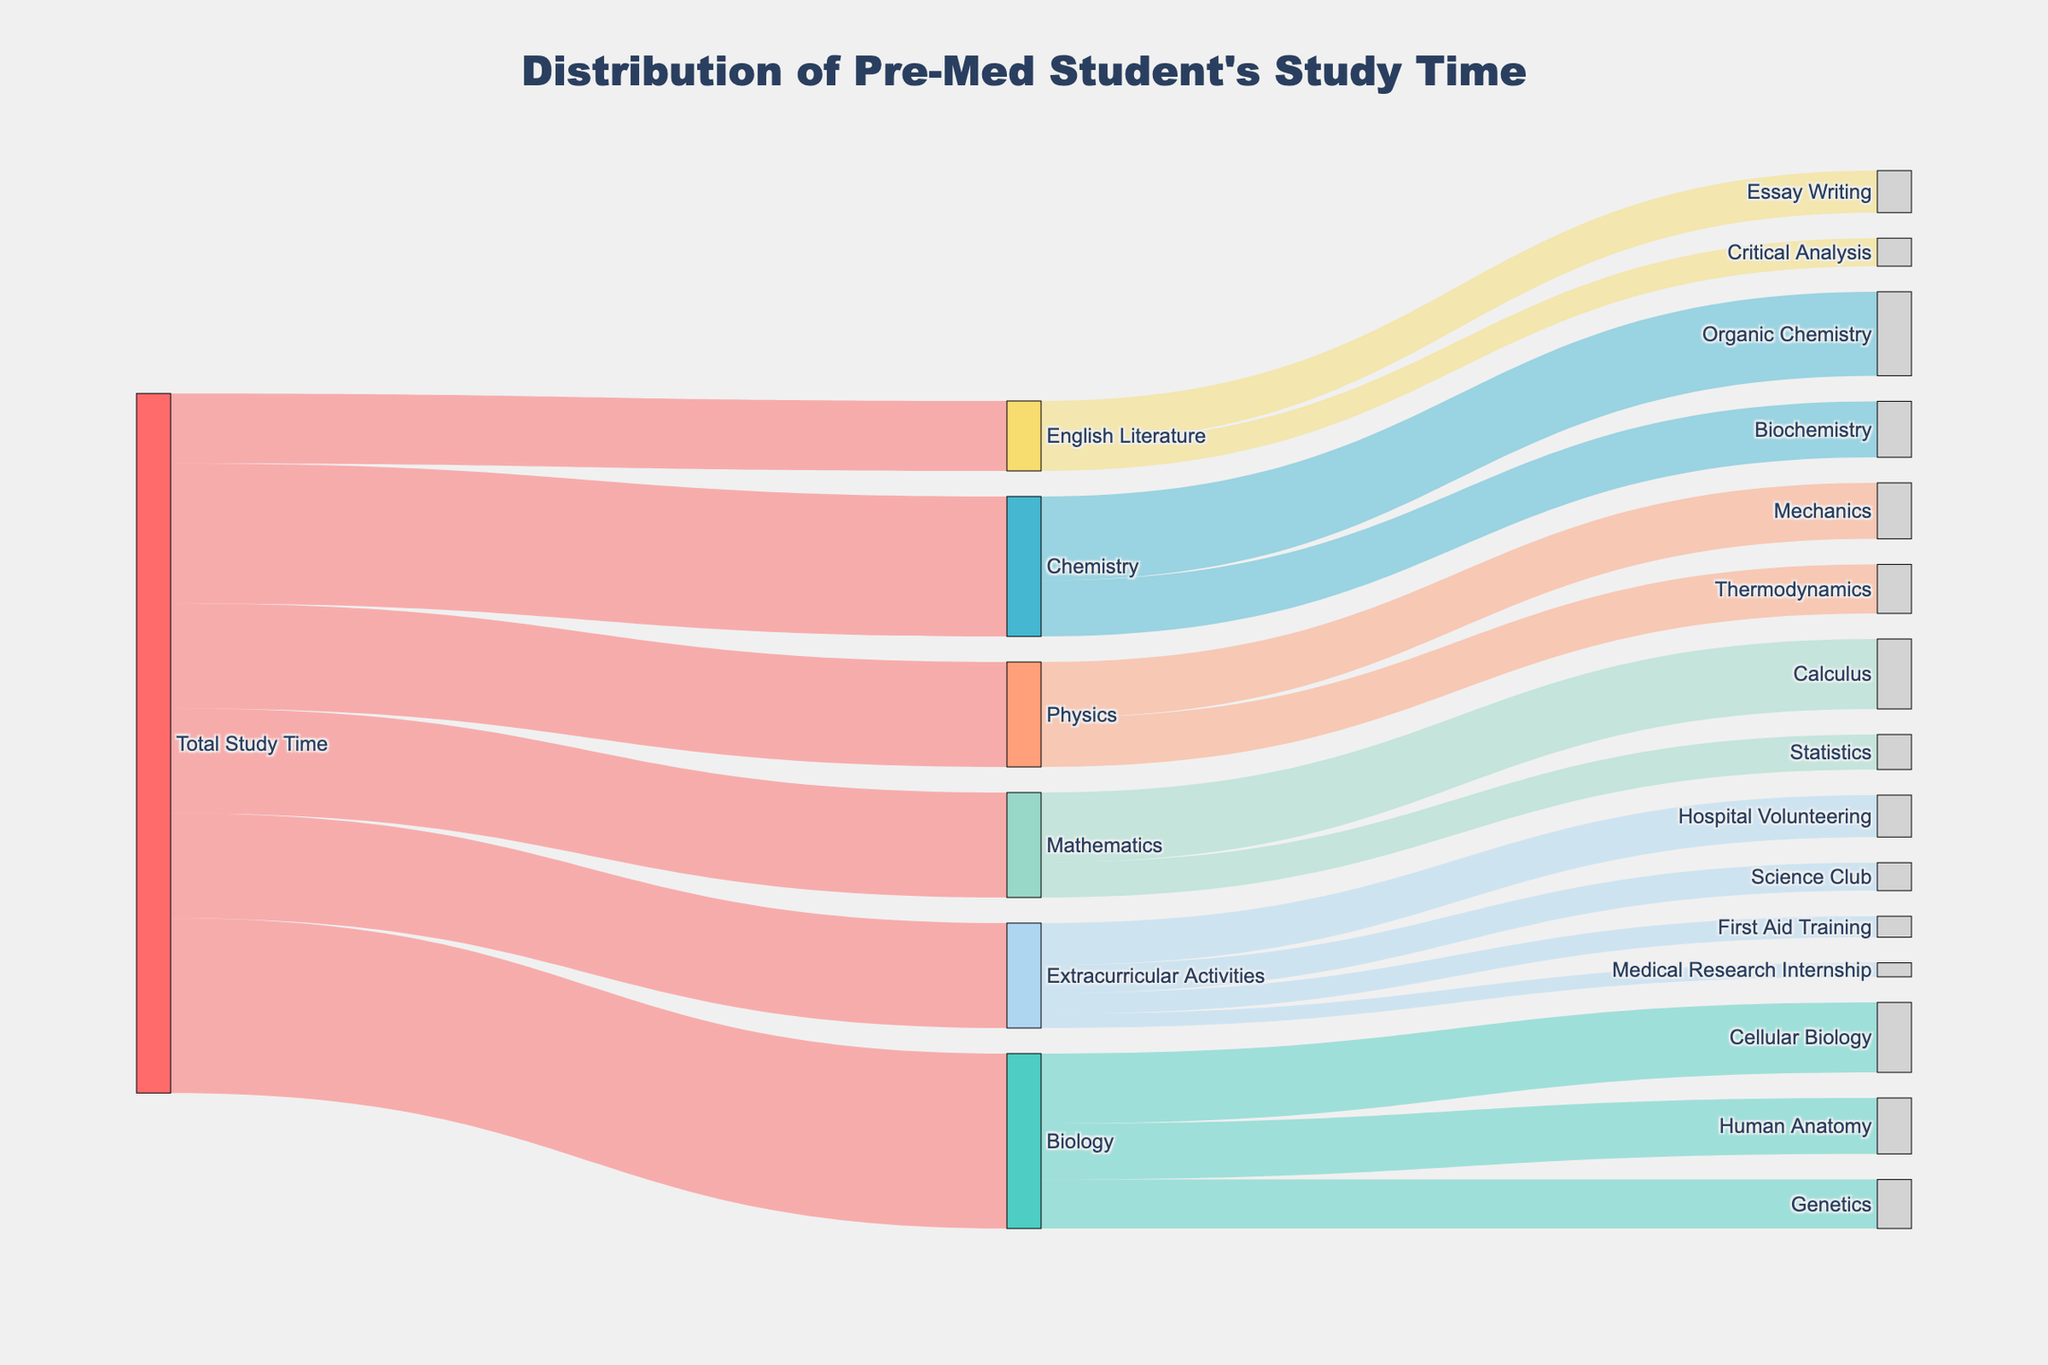What's the total amount of study time dedicated to Biology? The flow from "Total Study Time" to "Biology" represents the total study time dedicated to Biology, which is labeled as 25.
Answer: 25 Which subject gets the most study time? The links originating from "Total Study Time" show the values for each subject. The largest value among these is for "Biology" with 25 units of time.
Answer: Biology How much more time is spent on Chemistry than on Physics? Time for Chemistry is 20, and time for Physics is 15. The difference is 20 - 15.
Answer: 5 What percent of the total study time is allocated to Extracurricular Activities? Extracurricular Activities gets 15 units of time. The total time is 100 units. The percentage is (15/100) * 100%.
Answer: 15% Which activity under Extracurricular Activities has the least amount of time? The values for activities under Extracurricular Activities are 6, 4, 3, and 2. The smallest value is 2 for "Medical Research Internship".
Answer: Medical Research Internship Is more time spent on Calculus or on Statistics within Mathematics? The time dedicated to Calculus is 10, whereas for Statistics it is 5. Thus, more time is spent on Calculus.
Answer: Calculus Compare the study time for Organic Chemistry and Biochemistry. Which one has more study time? Organic Chemistry gets 12 units of time, whereas Biochemistry gets 8 units. Organic Chemistry has more study time.
Answer: Organic Chemistry How much total study time is spent on all topics within Biology? Adding up all the values for Cellular Biology, Human Anatomy, and Genetics: 10 + 8 + 7.
Answer: 25 Does more time get spent on Cellular Biology or Mechanics? Cellular Biology has 10 units of time and Mechanics has 8 units. Thus, more time is spent on Cellular Biology.
Answer: Cellular Biology What are the two main activities involving the most time under Extracurricular Activities? Hospital Volunteering has 6 units and Science Club has 4 units, which are the two highest values among the activities listed.
Answer: Hospital Volunteering, Science Club 